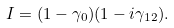<formula> <loc_0><loc_0><loc_500><loc_500>I = ( 1 - \gamma _ { 0 } ) ( 1 - i \gamma _ { 1 2 } ) .</formula> 